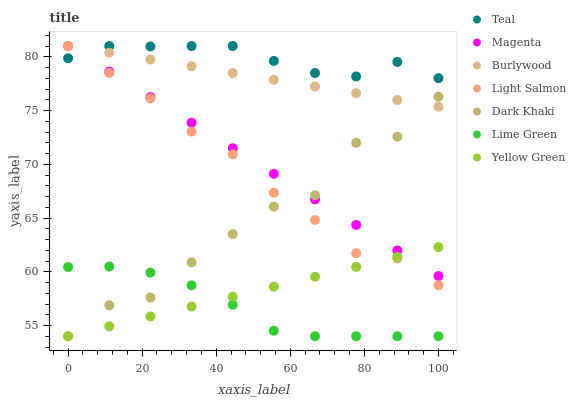Does Lime Green have the minimum area under the curve?
Answer yes or no. Yes. Does Teal have the maximum area under the curve?
Answer yes or no. Yes. Does Yellow Green have the minimum area under the curve?
Answer yes or no. No. Does Yellow Green have the maximum area under the curve?
Answer yes or no. No. Is Yellow Green the smoothest?
Answer yes or no. Yes. Is Dark Khaki the roughest?
Answer yes or no. Yes. Is Burlywood the smoothest?
Answer yes or no. No. Is Burlywood the roughest?
Answer yes or no. No. Does Yellow Green have the lowest value?
Answer yes or no. Yes. Does Burlywood have the lowest value?
Answer yes or no. No. Does Magenta have the highest value?
Answer yes or no. Yes. Does Yellow Green have the highest value?
Answer yes or no. No. Is Lime Green less than Magenta?
Answer yes or no. Yes. Is Teal greater than Lime Green?
Answer yes or no. Yes. Does Burlywood intersect Teal?
Answer yes or no. Yes. Is Burlywood less than Teal?
Answer yes or no. No. Is Burlywood greater than Teal?
Answer yes or no. No. Does Lime Green intersect Magenta?
Answer yes or no. No. 